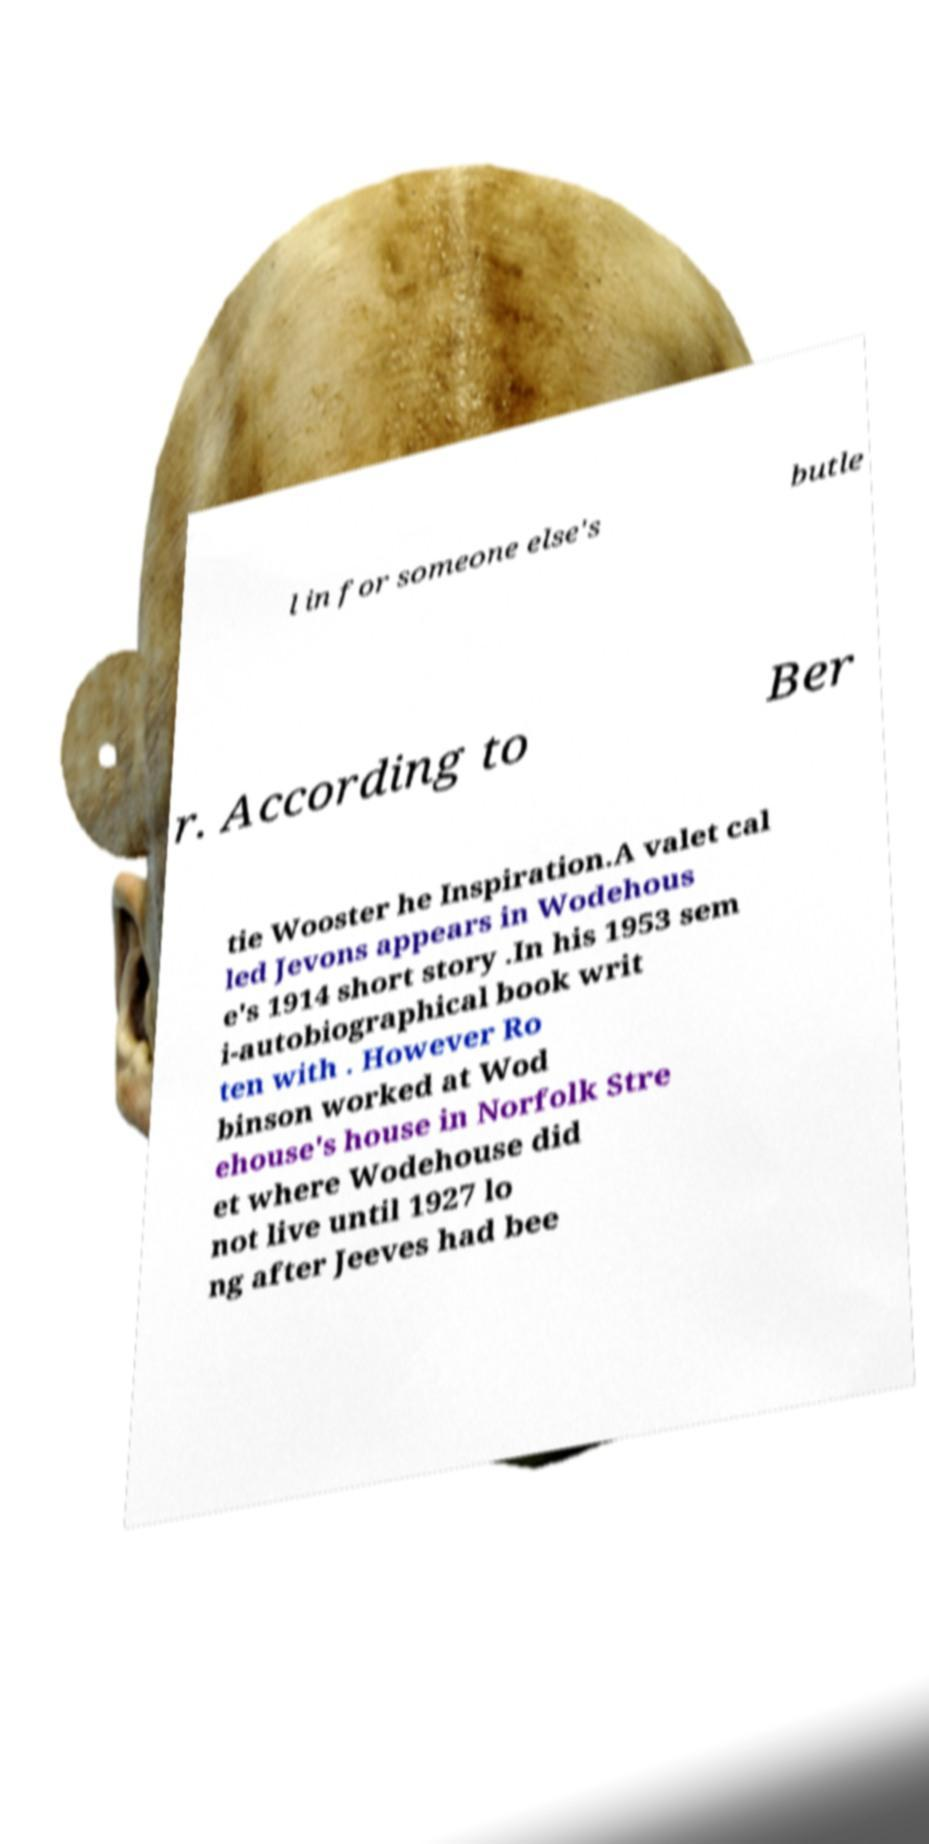Can you read and provide the text displayed in the image?This photo seems to have some interesting text. Can you extract and type it out for me? l in for someone else's butle r. According to Ber tie Wooster he Inspiration.A valet cal led Jevons appears in Wodehous e's 1914 short story .In his 1953 sem i-autobiographical book writ ten with . However Ro binson worked at Wod ehouse's house in Norfolk Stre et where Wodehouse did not live until 1927 lo ng after Jeeves had bee 